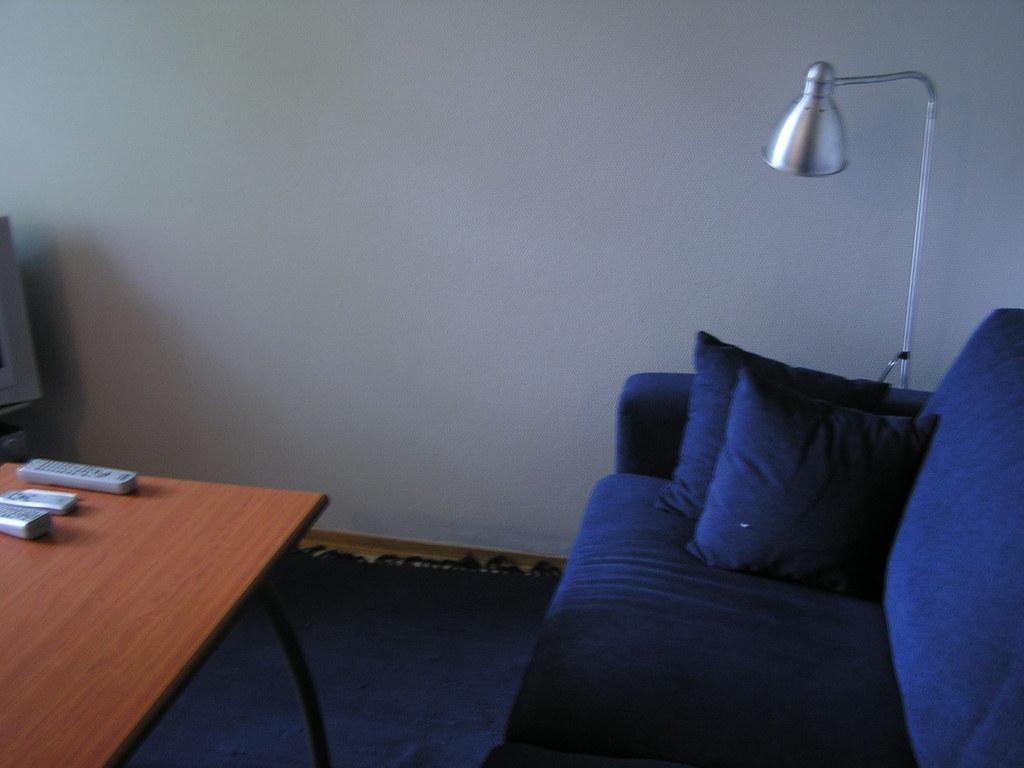What type of furniture is in the room? There is a blue sofa in the room. Can you describe the cushions on the sofa? There are two cushions on the right side of the sofa. What is located on the left side of the room? There is a table on the left side of the room. What items can be found on the table? There are remotes on the table. Where is the light in the room? The light is at the right back of the room. What color is the light? The light is silver colored. What type of bird is perched on the wren in the image? There is no bird or wren present in the image. 